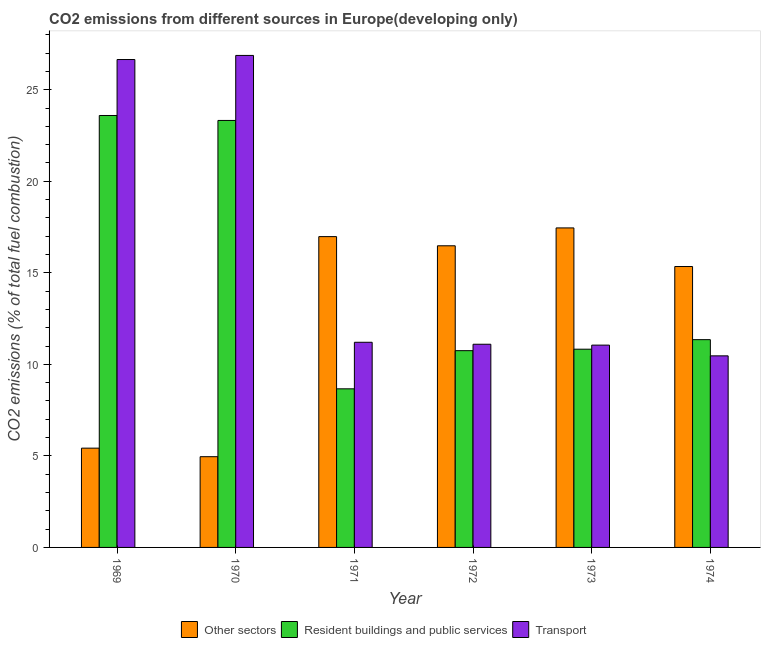Are the number of bars per tick equal to the number of legend labels?
Make the answer very short. Yes. Are the number of bars on each tick of the X-axis equal?
Give a very brief answer. Yes. How many bars are there on the 3rd tick from the left?
Provide a succinct answer. 3. How many bars are there on the 3rd tick from the right?
Your response must be concise. 3. What is the label of the 5th group of bars from the left?
Provide a short and direct response. 1973. What is the percentage of co2 emissions from other sectors in 1969?
Your answer should be very brief. 5.42. Across all years, what is the maximum percentage of co2 emissions from resident buildings and public services?
Provide a succinct answer. 23.59. Across all years, what is the minimum percentage of co2 emissions from other sectors?
Keep it short and to the point. 4.96. In which year was the percentage of co2 emissions from resident buildings and public services maximum?
Ensure brevity in your answer.  1969. In which year was the percentage of co2 emissions from other sectors minimum?
Your response must be concise. 1970. What is the total percentage of co2 emissions from resident buildings and public services in the graph?
Make the answer very short. 88.51. What is the difference between the percentage of co2 emissions from other sectors in 1970 and that in 1972?
Provide a short and direct response. -11.52. What is the difference between the percentage of co2 emissions from resident buildings and public services in 1969 and the percentage of co2 emissions from other sectors in 1971?
Ensure brevity in your answer.  14.93. What is the average percentage of co2 emissions from other sectors per year?
Your answer should be very brief. 12.77. In the year 1969, what is the difference between the percentage of co2 emissions from resident buildings and public services and percentage of co2 emissions from transport?
Offer a terse response. 0. In how many years, is the percentage of co2 emissions from resident buildings and public services greater than 3 %?
Offer a terse response. 6. What is the ratio of the percentage of co2 emissions from other sectors in 1971 to that in 1974?
Offer a terse response. 1.11. What is the difference between the highest and the second highest percentage of co2 emissions from resident buildings and public services?
Your response must be concise. 0.27. What is the difference between the highest and the lowest percentage of co2 emissions from other sectors?
Your answer should be very brief. 12.5. What does the 2nd bar from the left in 1969 represents?
Your answer should be compact. Resident buildings and public services. What does the 1st bar from the right in 1969 represents?
Offer a terse response. Transport. How many bars are there?
Keep it short and to the point. 18. What is the difference between two consecutive major ticks on the Y-axis?
Offer a terse response. 5. What is the title of the graph?
Your answer should be compact. CO2 emissions from different sources in Europe(developing only). Does "Other sectors" appear as one of the legend labels in the graph?
Make the answer very short. Yes. What is the label or title of the X-axis?
Make the answer very short. Year. What is the label or title of the Y-axis?
Your answer should be very brief. CO2 emissions (% of total fuel combustion). What is the CO2 emissions (% of total fuel combustion) in Other sectors in 1969?
Your answer should be compact. 5.42. What is the CO2 emissions (% of total fuel combustion) of Resident buildings and public services in 1969?
Provide a succinct answer. 23.59. What is the CO2 emissions (% of total fuel combustion) in Transport in 1969?
Provide a succinct answer. 26.65. What is the CO2 emissions (% of total fuel combustion) of Other sectors in 1970?
Your response must be concise. 4.96. What is the CO2 emissions (% of total fuel combustion) in Resident buildings and public services in 1970?
Offer a terse response. 23.32. What is the CO2 emissions (% of total fuel combustion) in Transport in 1970?
Your answer should be very brief. 26.88. What is the CO2 emissions (% of total fuel combustion) of Other sectors in 1971?
Ensure brevity in your answer.  16.98. What is the CO2 emissions (% of total fuel combustion) of Resident buildings and public services in 1971?
Your answer should be compact. 8.66. What is the CO2 emissions (% of total fuel combustion) in Transport in 1971?
Your answer should be very brief. 11.21. What is the CO2 emissions (% of total fuel combustion) in Other sectors in 1972?
Provide a succinct answer. 16.48. What is the CO2 emissions (% of total fuel combustion) in Resident buildings and public services in 1972?
Make the answer very short. 10.75. What is the CO2 emissions (% of total fuel combustion) of Transport in 1972?
Your answer should be very brief. 11.1. What is the CO2 emissions (% of total fuel combustion) in Other sectors in 1973?
Keep it short and to the point. 17.45. What is the CO2 emissions (% of total fuel combustion) in Resident buildings and public services in 1973?
Ensure brevity in your answer.  10.83. What is the CO2 emissions (% of total fuel combustion) in Transport in 1973?
Your response must be concise. 11.05. What is the CO2 emissions (% of total fuel combustion) of Other sectors in 1974?
Give a very brief answer. 15.34. What is the CO2 emissions (% of total fuel combustion) of Resident buildings and public services in 1974?
Your answer should be very brief. 11.35. What is the CO2 emissions (% of total fuel combustion) of Transport in 1974?
Make the answer very short. 10.46. Across all years, what is the maximum CO2 emissions (% of total fuel combustion) in Other sectors?
Keep it short and to the point. 17.45. Across all years, what is the maximum CO2 emissions (% of total fuel combustion) in Resident buildings and public services?
Your response must be concise. 23.59. Across all years, what is the maximum CO2 emissions (% of total fuel combustion) in Transport?
Provide a short and direct response. 26.88. Across all years, what is the minimum CO2 emissions (% of total fuel combustion) of Other sectors?
Ensure brevity in your answer.  4.96. Across all years, what is the minimum CO2 emissions (% of total fuel combustion) of Resident buildings and public services?
Your response must be concise. 8.66. Across all years, what is the minimum CO2 emissions (% of total fuel combustion) of Transport?
Ensure brevity in your answer.  10.46. What is the total CO2 emissions (% of total fuel combustion) of Other sectors in the graph?
Offer a terse response. 76.63. What is the total CO2 emissions (% of total fuel combustion) of Resident buildings and public services in the graph?
Offer a very short reply. 88.51. What is the total CO2 emissions (% of total fuel combustion) of Transport in the graph?
Your answer should be very brief. 97.35. What is the difference between the CO2 emissions (% of total fuel combustion) of Other sectors in 1969 and that in 1970?
Make the answer very short. 0.47. What is the difference between the CO2 emissions (% of total fuel combustion) in Resident buildings and public services in 1969 and that in 1970?
Make the answer very short. 0.27. What is the difference between the CO2 emissions (% of total fuel combustion) of Transport in 1969 and that in 1970?
Keep it short and to the point. -0.22. What is the difference between the CO2 emissions (% of total fuel combustion) of Other sectors in 1969 and that in 1971?
Offer a very short reply. -11.55. What is the difference between the CO2 emissions (% of total fuel combustion) in Resident buildings and public services in 1969 and that in 1971?
Offer a very short reply. 14.93. What is the difference between the CO2 emissions (% of total fuel combustion) in Transport in 1969 and that in 1971?
Offer a terse response. 15.45. What is the difference between the CO2 emissions (% of total fuel combustion) in Other sectors in 1969 and that in 1972?
Your response must be concise. -11.05. What is the difference between the CO2 emissions (% of total fuel combustion) in Resident buildings and public services in 1969 and that in 1972?
Your response must be concise. 12.85. What is the difference between the CO2 emissions (% of total fuel combustion) of Transport in 1969 and that in 1972?
Offer a very short reply. 15.55. What is the difference between the CO2 emissions (% of total fuel combustion) in Other sectors in 1969 and that in 1973?
Your answer should be compact. -12.03. What is the difference between the CO2 emissions (% of total fuel combustion) of Resident buildings and public services in 1969 and that in 1973?
Give a very brief answer. 12.77. What is the difference between the CO2 emissions (% of total fuel combustion) of Transport in 1969 and that in 1973?
Provide a succinct answer. 15.6. What is the difference between the CO2 emissions (% of total fuel combustion) of Other sectors in 1969 and that in 1974?
Keep it short and to the point. -9.92. What is the difference between the CO2 emissions (% of total fuel combustion) of Resident buildings and public services in 1969 and that in 1974?
Provide a succinct answer. 12.24. What is the difference between the CO2 emissions (% of total fuel combustion) in Transport in 1969 and that in 1974?
Offer a very short reply. 16.19. What is the difference between the CO2 emissions (% of total fuel combustion) in Other sectors in 1970 and that in 1971?
Offer a very short reply. -12.02. What is the difference between the CO2 emissions (% of total fuel combustion) of Resident buildings and public services in 1970 and that in 1971?
Your answer should be very brief. 14.66. What is the difference between the CO2 emissions (% of total fuel combustion) of Transport in 1970 and that in 1971?
Provide a short and direct response. 15.67. What is the difference between the CO2 emissions (% of total fuel combustion) in Other sectors in 1970 and that in 1972?
Your answer should be compact. -11.52. What is the difference between the CO2 emissions (% of total fuel combustion) of Resident buildings and public services in 1970 and that in 1972?
Provide a succinct answer. 12.58. What is the difference between the CO2 emissions (% of total fuel combustion) in Transport in 1970 and that in 1972?
Give a very brief answer. 15.78. What is the difference between the CO2 emissions (% of total fuel combustion) in Other sectors in 1970 and that in 1973?
Keep it short and to the point. -12.5. What is the difference between the CO2 emissions (% of total fuel combustion) of Resident buildings and public services in 1970 and that in 1973?
Provide a succinct answer. 12.49. What is the difference between the CO2 emissions (% of total fuel combustion) in Transport in 1970 and that in 1973?
Your answer should be compact. 15.82. What is the difference between the CO2 emissions (% of total fuel combustion) in Other sectors in 1970 and that in 1974?
Your answer should be compact. -10.39. What is the difference between the CO2 emissions (% of total fuel combustion) of Resident buildings and public services in 1970 and that in 1974?
Offer a terse response. 11.97. What is the difference between the CO2 emissions (% of total fuel combustion) of Transport in 1970 and that in 1974?
Offer a very short reply. 16.41. What is the difference between the CO2 emissions (% of total fuel combustion) in Other sectors in 1971 and that in 1972?
Give a very brief answer. 0.5. What is the difference between the CO2 emissions (% of total fuel combustion) of Resident buildings and public services in 1971 and that in 1972?
Give a very brief answer. -2.08. What is the difference between the CO2 emissions (% of total fuel combustion) in Transport in 1971 and that in 1972?
Your answer should be very brief. 0.11. What is the difference between the CO2 emissions (% of total fuel combustion) in Other sectors in 1971 and that in 1973?
Give a very brief answer. -0.48. What is the difference between the CO2 emissions (% of total fuel combustion) of Resident buildings and public services in 1971 and that in 1973?
Your answer should be very brief. -2.16. What is the difference between the CO2 emissions (% of total fuel combustion) of Transport in 1971 and that in 1973?
Give a very brief answer. 0.16. What is the difference between the CO2 emissions (% of total fuel combustion) of Other sectors in 1971 and that in 1974?
Provide a succinct answer. 1.63. What is the difference between the CO2 emissions (% of total fuel combustion) in Resident buildings and public services in 1971 and that in 1974?
Your answer should be compact. -2.69. What is the difference between the CO2 emissions (% of total fuel combustion) of Transport in 1971 and that in 1974?
Offer a terse response. 0.74. What is the difference between the CO2 emissions (% of total fuel combustion) in Other sectors in 1972 and that in 1973?
Offer a very short reply. -0.98. What is the difference between the CO2 emissions (% of total fuel combustion) in Resident buildings and public services in 1972 and that in 1973?
Your answer should be compact. -0.08. What is the difference between the CO2 emissions (% of total fuel combustion) of Transport in 1972 and that in 1973?
Offer a very short reply. 0.05. What is the difference between the CO2 emissions (% of total fuel combustion) in Other sectors in 1972 and that in 1974?
Your answer should be very brief. 1.13. What is the difference between the CO2 emissions (% of total fuel combustion) of Resident buildings and public services in 1972 and that in 1974?
Your answer should be compact. -0.6. What is the difference between the CO2 emissions (% of total fuel combustion) of Transport in 1972 and that in 1974?
Ensure brevity in your answer.  0.63. What is the difference between the CO2 emissions (% of total fuel combustion) of Other sectors in 1973 and that in 1974?
Your answer should be compact. 2.11. What is the difference between the CO2 emissions (% of total fuel combustion) of Resident buildings and public services in 1973 and that in 1974?
Provide a short and direct response. -0.52. What is the difference between the CO2 emissions (% of total fuel combustion) in Transport in 1973 and that in 1974?
Your answer should be compact. 0.59. What is the difference between the CO2 emissions (% of total fuel combustion) in Other sectors in 1969 and the CO2 emissions (% of total fuel combustion) in Resident buildings and public services in 1970?
Provide a succinct answer. -17.9. What is the difference between the CO2 emissions (% of total fuel combustion) in Other sectors in 1969 and the CO2 emissions (% of total fuel combustion) in Transport in 1970?
Provide a short and direct response. -21.45. What is the difference between the CO2 emissions (% of total fuel combustion) of Resident buildings and public services in 1969 and the CO2 emissions (% of total fuel combustion) of Transport in 1970?
Keep it short and to the point. -3.28. What is the difference between the CO2 emissions (% of total fuel combustion) in Other sectors in 1969 and the CO2 emissions (% of total fuel combustion) in Resident buildings and public services in 1971?
Make the answer very short. -3.24. What is the difference between the CO2 emissions (% of total fuel combustion) in Other sectors in 1969 and the CO2 emissions (% of total fuel combustion) in Transport in 1971?
Offer a very short reply. -5.78. What is the difference between the CO2 emissions (% of total fuel combustion) of Resident buildings and public services in 1969 and the CO2 emissions (% of total fuel combustion) of Transport in 1971?
Provide a short and direct response. 12.39. What is the difference between the CO2 emissions (% of total fuel combustion) of Other sectors in 1969 and the CO2 emissions (% of total fuel combustion) of Resident buildings and public services in 1972?
Make the answer very short. -5.33. What is the difference between the CO2 emissions (% of total fuel combustion) in Other sectors in 1969 and the CO2 emissions (% of total fuel combustion) in Transport in 1972?
Ensure brevity in your answer.  -5.68. What is the difference between the CO2 emissions (% of total fuel combustion) of Resident buildings and public services in 1969 and the CO2 emissions (% of total fuel combustion) of Transport in 1972?
Your answer should be very brief. 12.49. What is the difference between the CO2 emissions (% of total fuel combustion) of Other sectors in 1969 and the CO2 emissions (% of total fuel combustion) of Resident buildings and public services in 1973?
Your answer should be compact. -5.41. What is the difference between the CO2 emissions (% of total fuel combustion) of Other sectors in 1969 and the CO2 emissions (% of total fuel combustion) of Transport in 1973?
Provide a succinct answer. -5.63. What is the difference between the CO2 emissions (% of total fuel combustion) in Resident buildings and public services in 1969 and the CO2 emissions (% of total fuel combustion) in Transport in 1973?
Provide a succinct answer. 12.54. What is the difference between the CO2 emissions (% of total fuel combustion) of Other sectors in 1969 and the CO2 emissions (% of total fuel combustion) of Resident buildings and public services in 1974?
Provide a succinct answer. -5.93. What is the difference between the CO2 emissions (% of total fuel combustion) of Other sectors in 1969 and the CO2 emissions (% of total fuel combustion) of Transport in 1974?
Offer a terse response. -5.04. What is the difference between the CO2 emissions (% of total fuel combustion) of Resident buildings and public services in 1969 and the CO2 emissions (% of total fuel combustion) of Transport in 1974?
Your response must be concise. 13.13. What is the difference between the CO2 emissions (% of total fuel combustion) of Other sectors in 1970 and the CO2 emissions (% of total fuel combustion) of Resident buildings and public services in 1971?
Give a very brief answer. -3.71. What is the difference between the CO2 emissions (% of total fuel combustion) of Other sectors in 1970 and the CO2 emissions (% of total fuel combustion) of Transport in 1971?
Your answer should be very brief. -6.25. What is the difference between the CO2 emissions (% of total fuel combustion) of Resident buildings and public services in 1970 and the CO2 emissions (% of total fuel combustion) of Transport in 1971?
Offer a very short reply. 12.12. What is the difference between the CO2 emissions (% of total fuel combustion) in Other sectors in 1970 and the CO2 emissions (% of total fuel combustion) in Resident buildings and public services in 1972?
Make the answer very short. -5.79. What is the difference between the CO2 emissions (% of total fuel combustion) of Other sectors in 1970 and the CO2 emissions (% of total fuel combustion) of Transport in 1972?
Ensure brevity in your answer.  -6.14. What is the difference between the CO2 emissions (% of total fuel combustion) of Resident buildings and public services in 1970 and the CO2 emissions (% of total fuel combustion) of Transport in 1972?
Ensure brevity in your answer.  12.22. What is the difference between the CO2 emissions (% of total fuel combustion) in Other sectors in 1970 and the CO2 emissions (% of total fuel combustion) in Resident buildings and public services in 1973?
Your response must be concise. -5.87. What is the difference between the CO2 emissions (% of total fuel combustion) of Other sectors in 1970 and the CO2 emissions (% of total fuel combustion) of Transport in 1973?
Provide a short and direct response. -6.09. What is the difference between the CO2 emissions (% of total fuel combustion) in Resident buildings and public services in 1970 and the CO2 emissions (% of total fuel combustion) in Transport in 1973?
Offer a terse response. 12.27. What is the difference between the CO2 emissions (% of total fuel combustion) in Other sectors in 1970 and the CO2 emissions (% of total fuel combustion) in Resident buildings and public services in 1974?
Offer a terse response. -6.39. What is the difference between the CO2 emissions (% of total fuel combustion) in Other sectors in 1970 and the CO2 emissions (% of total fuel combustion) in Transport in 1974?
Ensure brevity in your answer.  -5.51. What is the difference between the CO2 emissions (% of total fuel combustion) of Resident buildings and public services in 1970 and the CO2 emissions (% of total fuel combustion) of Transport in 1974?
Offer a terse response. 12.86. What is the difference between the CO2 emissions (% of total fuel combustion) of Other sectors in 1971 and the CO2 emissions (% of total fuel combustion) of Resident buildings and public services in 1972?
Offer a terse response. 6.23. What is the difference between the CO2 emissions (% of total fuel combustion) in Other sectors in 1971 and the CO2 emissions (% of total fuel combustion) in Transport in 1972?
Keep it short and to the point. 5.88. What is the difference between the CO2 emissions (% of total fuel combustion) in Resident buildings and public services in 1971 and the CO2 emissions (% of total fuel combustion) in Transport in 1972?
Offer a very short reply. -2.44. What is the difference between the CO2 emissions (% of total fuel combustion) of Other sectors in 1971 and the CO2 emissions (% of total fuel combustion) of Resident buildings and public services in 1973?
Offer a very short reply. 6.15. What is the difference between the CO2 emissions (% of total fuel combustion) of Other sectors in 1971 and the CO2 emissions (% of total fuel combustion) of Transport in 1973?
Make the answer very short. 5.93. What is the difference between the CO2 emissions (% of total fuel combustion) in Resident buildings and public services in 1971 and the CO2 emissions (% of total fuel combustion) in Transport in 1973?
Offer a very short reply. -2.39. What is the difference between the CO2 emissions (% of total fuel combustion) of Other sectors in 1971 and the CO2 emissions (% of total fuel combustion) of Resident buildings and public services in 1974?
Offer a very short reply. 5.63. What is the difference between the CO2 emissions (% of total fuel combustion) of Other sectors in 1971 and the CO2 emissions (% of total fuel combustion) of Transport in 1974?
Make the answer very short. 6.51. What is the difference between the CO2 emissions (% of total fuel combustion) in Resident buildings and public services in 1971 and the CO2 emissions (% of total fuel combustion) in Transport in 1974?
Make the answer very short. -1.8. What is the difference between the CO2 emissions (% of total fuel combustion) of Other sectors in 1972 and the CO2 emissions (% of total fuel combustion) of Resident buildings and public services in 1973?
Provide a short and direct response. 5.65. What is the difference between the CO2 emissions (% of total fuel combustion) in Other sectors in 1972 and the CO2 emissions (% of total fuel combustion) in Transport in 1973?
Offer a terse response. 5.43. What is the difference between the CO2 emissions (% of total fuel combustion) in Resident buildings and public services in 1972 and the CO2 emissions (% of total fuel combustion) in Transport in 1973?
Your answer should be compact. -0.3. What is the difference between the CO2 emissions (% of total fuel combustion) in Other sectors in 1972 and the CO2 emissions (% of total fuel combustion) in Resident buildings and public services in 1974?
Offer a very short reply. 5.13. What is the difference between the CO2 emissions (% of total fuel combustion) of Other sectors in 1972 and the CO2 emissions (% of total fuel combustion) of Transport in 1974?
Make the answer very short. 6.01. What is the difference between the CO2 emissions (% of total fuel combustion) of Resident buildings and public services in 1972 and the CO2 emissions (% of total fuel combustion) of Transport in 1974?
Offer a very short reply. 0.28. What is the difference between the CO2 emissions (% of total fuel combustion) of Other sectors in 1973 and the CO2 emissions (% of total fuel combustion) of Resident buildings and public services in 1974?
Your answer should be very brief. 6.1. What is the difference between the CO2 emissions (% of total fuel combustion) of Other sectors in 1973 and the CO2 emissions (% of total fuel combustion) of Transport in 1974?
Your answer should be compact. 6.99. What is the difference between the CO2 emissions (% of total fuel combustion) of Resident buildings and public services in 1973 and the CO2 emissions (% of total fuel combustion) of Transport in 1974?
Offer a terse response. 0.36. What is the average CO2 emissions (% of total fuel combustion) in Other sectors per year?
Your answer should be very brief. 12.77. What is the average CO2 emissions (% of total fuel combustion) in Resident buildings and public services per year?
Offer a very short reply. 14.75. What is the average CO2 emissions (% of total fuel combustion) of Transport per year?
Your answer should be compact. 16.22. In the year 1969, what is the difference between the CO2 emissions (% of total fuel combustion) in Other sectors and CO2 emissions (% of total fuel combustion) in Resident buildings and public services?
Provide a succinct answer. -18.17. In the year 1969, what is the difference between the CO2 emissions (% of total fuel combustion) of Other sectors and CO2 emissions (% of total fuel combustion) of Transport?
Offer a very short reply. -21.23. In the year 1969, what is the difference between the CO2 emissions (% of total fuel combustion) of Resident buildings and public services and CO2 emissions (% of total fuel combustion) of Transport?
Give a very brief answer. -3.06. In the year 1970, what is the difference between the CO2 emissions (% of total fuel combustion) in Other sectors and CO2 emissions (% of total fuel combustion) in Resident buildings and public services?
Offer a terse response. -18.37. In the year 1970, what is the difference between the CO2 emissions (% of total fuel combustion) in Other sectors and CO2 emissions (% of total fuel combustion) in Transport?
Offer a terse response. -21.92. In the year 1970, what is the difference between the CO2 emissions (% of total fuel combustion) in Resident buildings and public services and CO2 emissions (% of total fuel combustion) in Transport?
Offer a terse response. -3.55. In the year 1971, what is the difference between the CO2 emissions (% of total fuel combustion) in Other sectors and CO2 emissions (% of total fuel combustion) in Resident buildings and public services?
Provide a short and direct response. 8.31. In the year 1971, what is the difference between the CO2 emissions (% of total fuel combustion) of Other sectors and CO2 emissions (% of total fuel combustion) of Transport?
Your answer should be very brief. 5.77. In the year 1971, what is the difference between the CO2 emissions (% of total fuel combustion) in Resident buildings and public services and CO2 emissions (% of total fuel combustion) in Transport?
Your answer should be compact. -2.54. In the year 1972, what is the difference between the CO2 emissions (% of total fuel combustion) in Other sectors and CO2 emissions (% of total fuel combustion) in Resident buildings and public services?
Give a very brief answer. 5.73. In the year 1972, what is the difference between the CO2 emissions (% of total fuel combustion) in Other sectors and CO2 emissions (% of total fuel combustion) in Transport?
Offer a terse response. 5.38. In the year 1972, what is the difference between the CO2 emissions (% of total fuel combustion) in Resident buildings and public services and CO2 emissions (% of total fuel combustion) in Transport?
Your response must be concise. -0.35. In the year 1973, what is the difference between the CO2 emissions (% of total fuel combustion) of Other sectors and CO2 emissions (% of total fuel combustion) of Resident buildings and public services?
Offer a very short reply. 6.62. In the year 1973, what is the difference between the CO2 emissions (% of total fuel combustion) of Other sectors and CO2 emissions (% of total fuel combustion) of Transport?
Ensure brevity in your answer.  6.4. In the year 1973, what is the difference between the CO2 emissions (% of total fuel combustion) in Resident buildings and public services and CO2 emissions (% of total fuel combustion) in Transport?
Your response must be concise. -0.22. In the year 1974, what is the difference between the CO2 emissions (% of total fuel combustion) of Other sectors and CO2 emissions (% of total fuel combustion) of Resident buildings and public services?
Your answer should be very brief. 3.99. In the year 1974, what is the difference between the CO2 emissions (% of total fuel combustion) in Other sectors and CO2 emissions (% of total fuel combustion) in Transport?
Give a very brief answer. 4.88. In the year 1974, what is the difference between the CO2 emissions (% of total fuel combustion) in Resident buildings and public services and CO2 emissions (% of total fuel combustion) in Transport?
Your answer should be very brief. 0.88. What is the ratio of the CO2 emissions (% of total fuel combustion) of Other sectors in 1969 to that in 1970?
Give a very brief answer. 1.09. What is the ratio of the CO2 emissions (% of total fuel combustion) of Resident buildings and public services in 1969 to that in 1970?
Make the answer very short. 1.01. What is the ratio of the CO2 emissions (% of total fuel combustion) in Other sectors in 1969 to that in 1971?
Offer a very short reply. 0.32. What is the ratio of the CO2 emissions (% of total fuel combustion) of Resident buildings and public services in 1969 to that in 1971?
Offer a terse response. 2.72. What is the ratio of the CO2 emissions (% of total fuel combustion) of Transport in 1969 to that in 1971?
Give a very brief answer. 2.38. What is the ratio of the CO2 emissions (% of total fuel combustion) of Other sectors in 1969 to that in 1972?
Your response must be concise. 0.33. What is the ratio of the CO2 emissions (% of total fuel combustion) in Resident buildings and public services in 1969 to that in 1972?
Make the answer very short. 2.2. What is the ratio of the CO2 emissions (% of total fuel combustion) in Transport in 1969 to that in 1972?
Give a very brief answer. 2.4. What is the ratio of the CO2 emissions (% of total fuel combustion) in Other sectors in 1969 to that in 1973?
Your response must be concise. 0.31. What is the ratio of the CO2 emissions (% of total fuel combustion) of Resident buildings and public services in 1969 to that in 1973?
Offer a terse response. 2.18. What is the ratio of the CO2 emissions (% of total fuel combustion) in Transport in 1969 to that in 1973?
Provide a succinct answer. 2.41. What is the ratio of the CO2 emissions (% of total fuel combustion) of Other sectors in 1969 to that in 1974?
Provide a succinct answer. 0.35. What is the ratio of the CO2 emissions (% of total fuel combustion) in Resident buildings and public services in 1969 to that in 1974?
Give a very brief answer. 2.08. What is the ratio of the CO2 emissions (% of total fuel combustion) in Transport in 1969 to that in 1974?
Offer a very short reply. 2.55. What is the ratio of the CO2 emissions (% of total fuel combustion) of Other sectors in 1970 to that in 1971?
Provide a succinct answer. 0.29. What is the ratio of the CO2 emissions (% of total fuel combustion) of Resident buildings and public services in 1970 to that in 1971?
Make the answer very short. 2.69. What is the ratio of the CO2 emissions (% of total fuel combustion) in Transport in 1970 to that in 1971?
Provide a succinct answer. 2.4. What is the ratio of the CO2 emissions (% of total fuel combustion) of Other sectors in 1970 to that in 1972?
Your answer should be very brief. 0.3. What is the ratio of the CO2 emissions (% of total fuel combustion) of Resident buildings and public services in 1970 to that in 1972?
Your answer should be very brief. 2.17. What is the ratio of the CO2 emissions (% of total fuel combustion) in Transport in 1970 to that in 1972?
Your answer should be very brief. 2.42. What is the ratio of the CO2 emissions (% of total fuel combustion) of Other sectors in 1970 to that in 1973?
Provide a short and direct response. 0.28. What is the ratio of the CO2 emissions (% of total fuel combustion) of Resident buildings and public services in 1970 to that in 1973?
Offer a very short reply. 2.15. What is the ratio of the CO2 emissions (% of total fuel combustion) of Transport in 1970 to that in 1973?
Keep it short and to the point. 2.43. What is the ratio of the CO2 emissions (% of total fuel combustion) of Other sectors in 1970 to that in 1974?
Ensure brevity in your answer.  0.32. What is the ratio of the CO2 emissions (% of total fuel combustion) in Resident buildings and public services in 1970 to that in 1974?
Offer a terse response. 2.06. What is the ratio of the CO2 emissions (% of total fuel combustion) in Transport in 1970 to that in 1974?
Give a very brief answer. 2.57. What is the ratio of the CO2 emissions (% of total fuel combustion) in Other sectors in 1971 to that in 1972?
Offer a very short reply. 1.03. What is the ratio of the CO2 emissions (% of total fuel combustion) in Resident buildings and public services in 1971 to that in 1972?
Make the answer very short. 0.81. What is the ratio of the CO2 emissions (% of total fuel combustion) of Transport in 1971 to that in 1972?
Your answer should be compact. 1.01. What is the ratio of the CO2 emissions (% of total fuel combustion) of Other sectors in 1971 to that in 1973?
Your response must be concise. 0.97. What is the ratio of the CO2 emissions (% of total fuel combustion) in Resident buildings and public services in 1971 to that in 1973?
Offer a very short reply. 0.8. What is the ratio of the CO2 emissions (% of total fuel combustion) in Transport in 1971 to that in 1973?
Your answer should be very brief. 1.01. What is the ratio of the CO2 emissions (% of total fuel combustion) in Other sectors in 1971 to that in 1974?
Ensure brevity in your answer.  1.11. What is the ratio of the CO2 emissions (% of total fuel combustion) in Resident buildings and public services in 1971 to that in 1974?
Keep it short and to the point. 0.76. What is the ratio of the CO2 emissions (% of total fuel combustion) of Transport in 1971 to that in 1974?
Your answer should be compact. 1.07. What is the ratio of the CO2 emissions (% of total fuel combustion) in Other sectors in 1972 to that in 1973?
Offer a very short reply. 0.94. What is the ratio of the CO2 emissions (% of total fuel combustion) of Transport in 1972 to that in 1973?
Keep it short and to the point. 1. What is the ratio of the CO2 emissions (% of total fuel combustion) in Other sectors in 1972 to that in 1974?
Provide a succinct answer. 1.07. What is the ratio of the CO2 emissions (% of total fuel combustion) in Resident buildings and public services in 1972 to that in 1974?
Your answer should be compact. 0.95. What is the ratio of the CO2 emissions (% of total fuel combustion) of Transport in 1972 to that in 1974?
Offer a terse response. 1.06. What is the ratio of the CO2 emissions (% of total fuel combustion) of Other sectors in 1973 to that in 1974?
Provide a succinct answer. 1.14. What is the ratio of the CO2 emissions (% of total fuel combustion) of Resident buildings and public services in 1973 to that in 1974?
Keep it short and to the point. 0.95. What is the ratio of the CO2 emissions (% of total fuel combustion) in Transport in 1973 to that in 1974?
Your answer should be compact. 1.06. What is the difference between the highest and the second highest CO2 emissions (% of total fuel combustion) in Other sectors?
Provide a succinct answer. 0.48. What is the difference between the highest and the second highest CO2 emissions (% of total fuel combustion) in Resident buildings and public services?
Offer a terse response. 0.27. What is the difference between the highest and the second highest CO2 emissions (% of total fuel combustion) in Transport?
Your response must be concise. 0.22. What is the difference between the highest and the lowest CO2 emissions (% of total fuel combustion) of Other sectors?
Your answer should be compact. 12.5. What is the difference between the highest and the lowest CO2 emissions (% of total fuel combustion) of Resident buildings and public services?
Provide a succinct answer. 14.93. What is the difference between the highest and the lowest CO2 emissions (% of total fuel combustion) of Transport?
Your answer should be very brief. 16.41. 